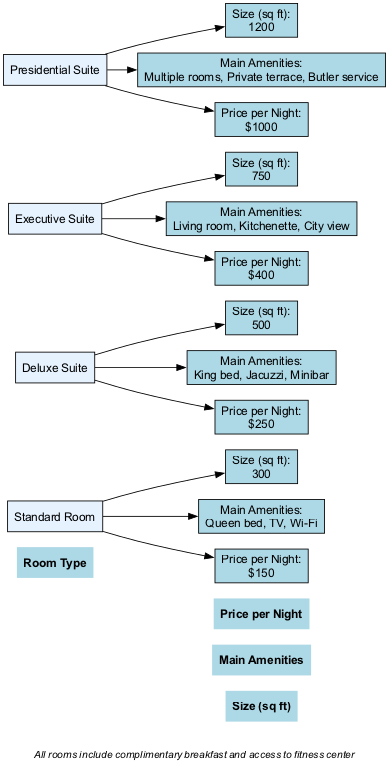What is the size of the Deluxe Suite? The Deluxe Suite is listed with a Size of 500 square feet in the diagram.
Answer: 500 sq ft How many main amenities does the Executive Suite offer? The Executive Suite's main amenities include a Living room, Kitchenette, and City view, totaling three main amenities.
Answer: 3 What is the price per night for the Presidential Suite? The diagram specifies the price per night for the Presidential Suite as $1000.
Answer: $1000 Which room type has the largest size? The diagram indicates that the Presidential Suite, with a size of 1200 square feet, is the largest room type.
Answer: Presidential Suite Compare the price per night of the Standard Room and Deluxe Suite. Which is more expensive? The Standard Room costs $150 per night and the Deluxe Suite costs $250 per night. Since $250 is greater than $150, the Deluxe Suite is the more expensive room.
Answer: Deluxe Suite Is there any room type that includes a private terrace? The diagram notes that the Presidential Suite includes a private terrace among its amenities, indicating it is the only room type with this feature.
Answer: Presidential Suite What amenities does the Standard Room include? The Standard Room has a Queen bed, TV, and Wi-Fi as its main amenities, as specified in the diagram.
Answer: Queen bed, TV, Wi-Fi How does the size of the Executive Suite compare to the Standard Room? The Executive Suite is listed at 750 square feet, which is 450 square feet larger than the Standard Room, which is 300 square feet. Therefore, the Executive Suite is substantially larger.
Answer: 450 sq ft larger What is the common feature of all rooms listed in the diagram? The footer provides information that all rooms include complimentary breakfast and access to the fitness center, which is a common feature across all room types.
Answer: Complimentary breakfast and access to fitness center 